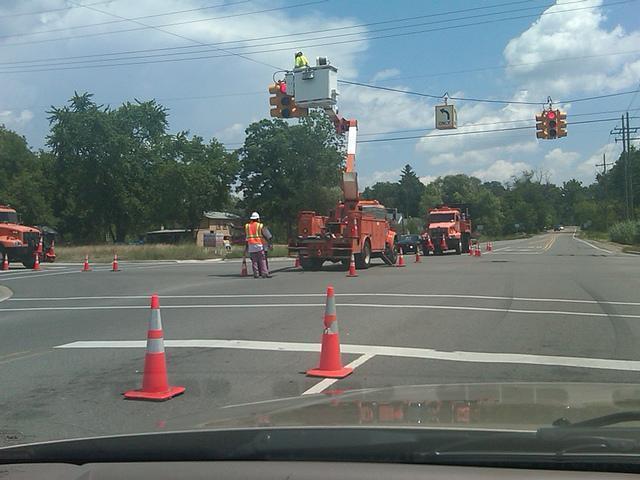How many horses without riders?
Give a very brief answer. 0. 